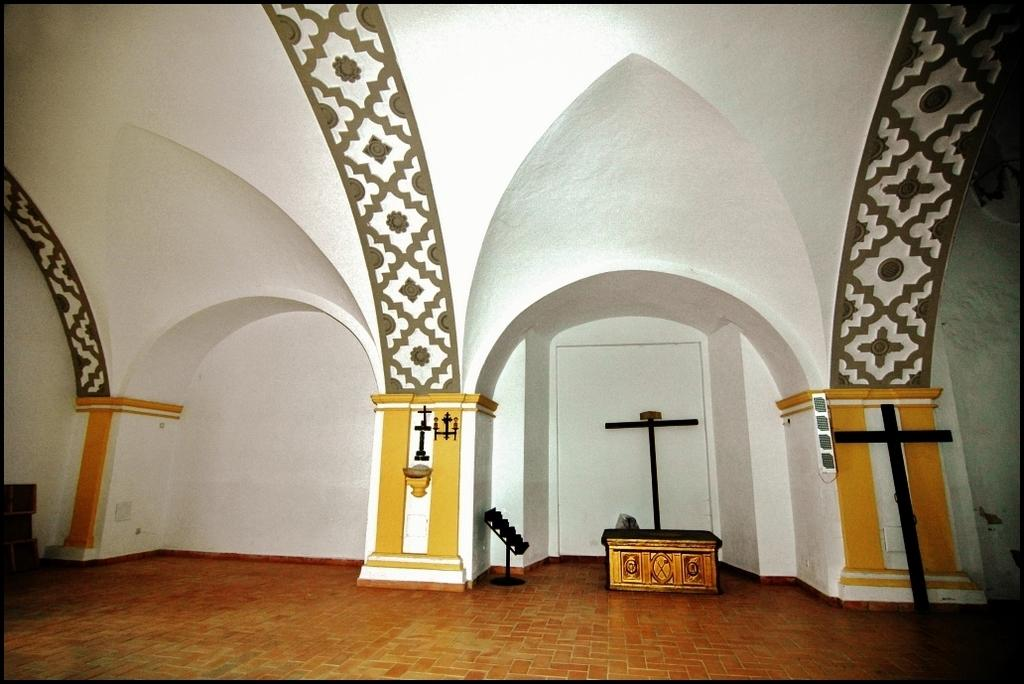How many pillars are visible in the image? There are three pillars in the image. What else can be seen in the image besides the pillars? There is a wooden box in the image. What type of story is the woman telling in the image? There is no woman present in the image, and therefore no storytelling can be observed. What color is the bucket in the image? There is no bucket present in the image. 